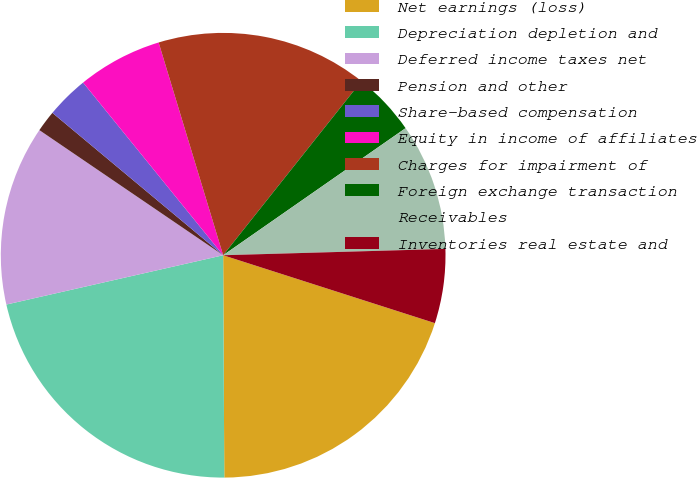Convert chart to OTSL. <chart><loc_0><loc_0><loc_500><loc_500><pie_chart><fcel>Net earnings (loss)<fcel>Depreciation depletion and<fcel>Deferred income taxes net<fcel>Pension and other<fcel>Share-based compensation<fcel>Equity in income of affiliates<fcel>Charges for impairment of<fcel>Foreign exchange transaction<fcel>Receivables<fcel>Inventories real estate and<nl><fcel>19.98%<fcel>21.52%<fcel>13.07%<fcel>1.55%<fcel>3.09%<fcel>6.16%<fcel>15.37%<fcel>4.63%<fcel>9.23%<fcel>5.39%<nl></chart> 